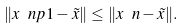<formula> <loc_0><loc_0><loc_500><loc_500>\| x \ n p 1 - \tilde { x } \| \leq \| x \ n - \tilde { x } \| .</formula> 